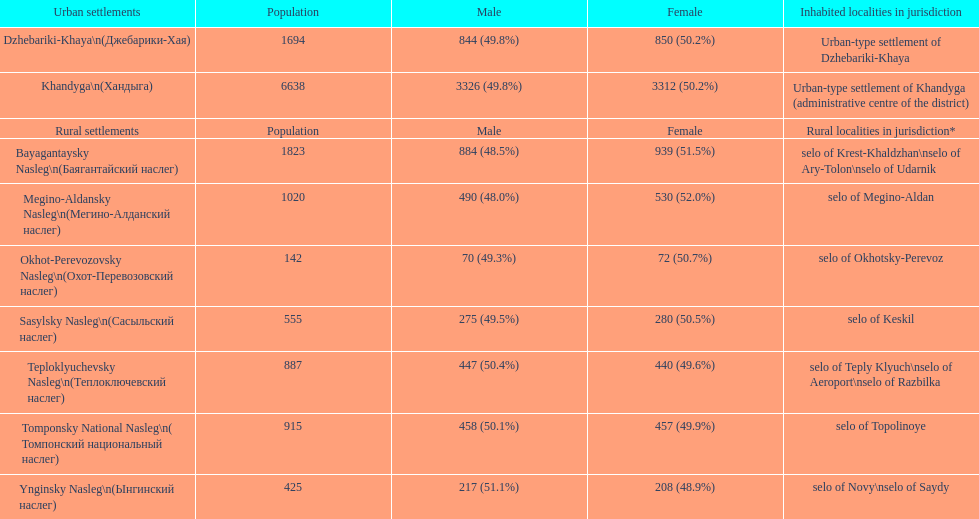I'm looking to parse the entire table for insights. Could you assist me with that? {'header': ['Urban settlements', 'Population', 'Male', 'Female', 'Inhabited localities in jurisdiction'], 'rows': [['Dzhebariki-Khaya\\n(Джебарики-Хая)', '1694', '844 (49.8%)', '850 (50.2%)', 'Urban-type settlement of Dzhebariki-Khaya'], ['Khandyga\\n(Хандыга)', '6638', '3326 (49.8%)', '3312 (50.2%)', 'Urban-type settlement of Khandyga (administrative centre of the district)'], ['Rural settlements', 'Population', 'Male', 'Female', 'Rural localities in jurisdiction*'], ['Bayagantaysky Nasleg\\n(Баягантайский наслег)', '1823', '884 (48.5%)', '939 (51.5%)', 'selo of Krest-Khaldzhan\\nselo of Ary-Tolon\\nselo of Udarnik'], ['Megino-Aldansky Nasleg\\n(Мегино-Алданский наслег)', '1020', '490 (48.0%)', '530 (52.0%)', 'selo of Megino-Aldan'], ['Okhot-Perevozovsky Nasleg\\n(Охот-Перевозовский наслег)', '142', '70 (49.3%)', '72 (50.7%)', 'selo of Okhotsky-Perevoz'], ['Sasylsky Nasleg\\n(Сасыльский наслег)', '555', '275 (49.5%)', '280 (50.5%)', 'selo of Keskil'], ['Teploklyuchevsky Nasleg\\n(Теплоключевский наслег)', '887', '447 (50.4%)', '440 (49.6%)', 'selo of Teply Klyuch\\nselo of Aeroport\\nselo of Razbilka'], ['Tomponsky National Nasleg\\n( Томпонский национальный наслег)', '915', '458 (50.1%)', '457 (49.9%)', 'selo of Topolinoye'], ['Ynginsky Nasleg\\n(Ынгинский наслег)', '425', '217 (51.1%)', '208 (48.9%)', 'selo of Novy\\nselo of Saydy']]} Which village settlement has the most significant male population? Bayagantaysky Nasleg (Áàÿãàíòàéñêèé íàñëåã). 